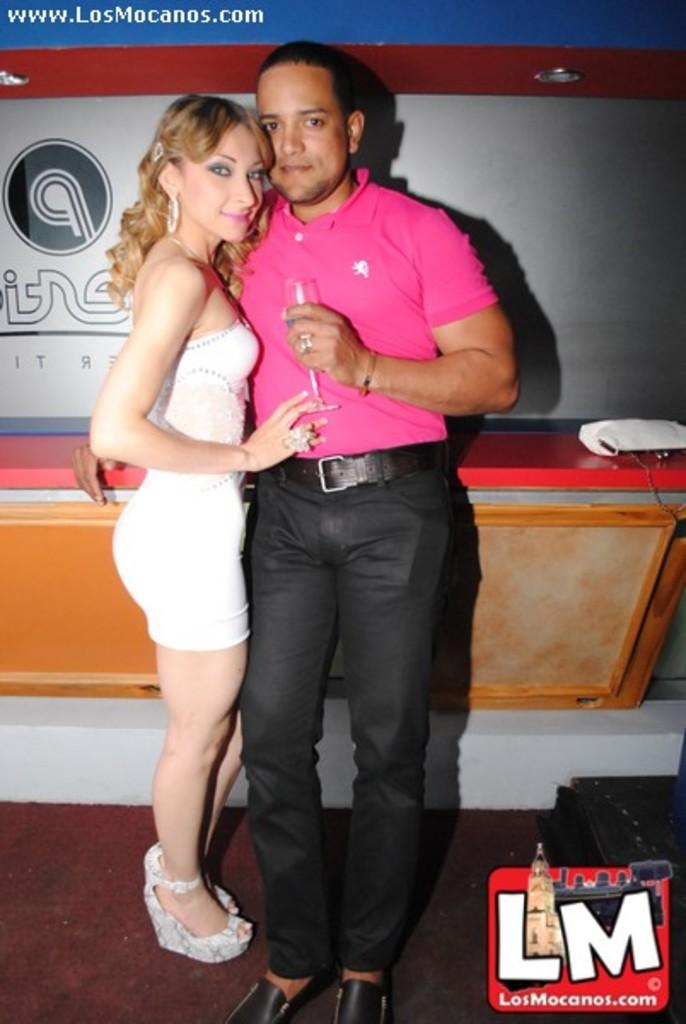Who are the two people in the center of the image? There is a man and a lady in the center of the image. What is one of them holding? One of them is holding a glass. What can be seen in the background of the image? There is a wall and a stand in the background of the image. Where is the logo located in the image? The logo is at the bottom of the image. What type of bed is visible in the image? There is no bed present in the image. Who is the son of the man and lady in the image? The image does not show any children or provide information about their family relationships. 